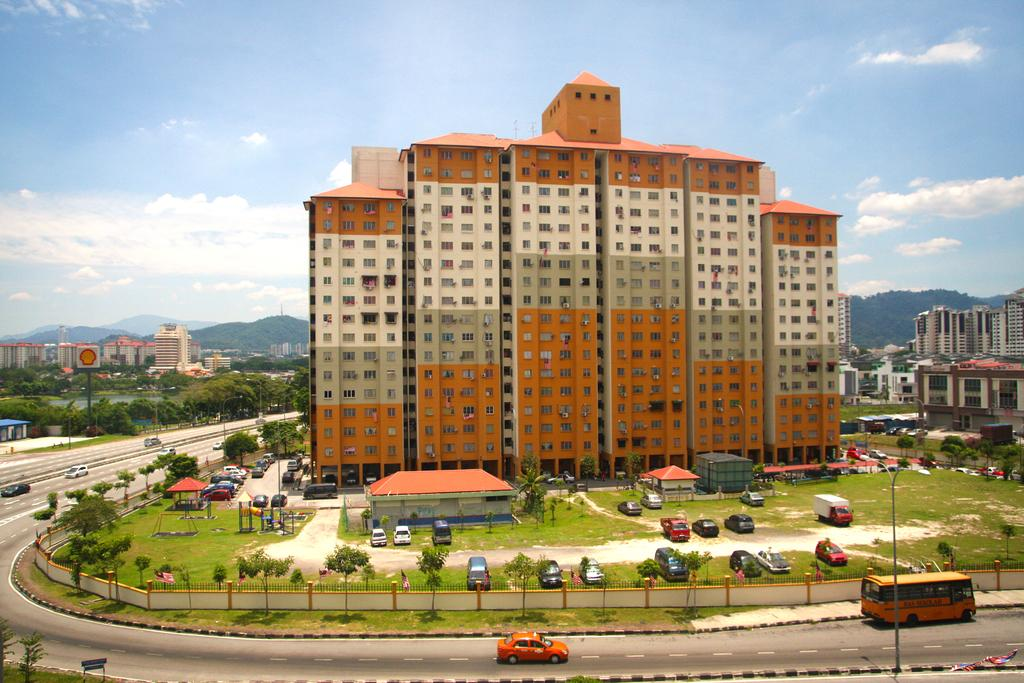What type of structures can be seen in the image? There are buildings, sheds, and railings visible in the image. What type of natural features are present in the image? There are hills and trees visible in the image. What type of man-made objects can be seen in the image? There are boards, lights, poles, and vehicles on the road visible in the image. What is the ground like in the image? There is ground visible in the image. What can be seen in the sky at the top of the image? There are clouds visible in the sky at the top of the image. Can you tell me how many fairies are flying around the buildings in the image? There are no fairies present in the image; it features buildings, hills, sheds, trees, boards, lights, poles, vehicles, ground, and clouds. What type of cart is being used to transport the vehicles in the image? There is no cart present in the image; it features vehicles on the road. 